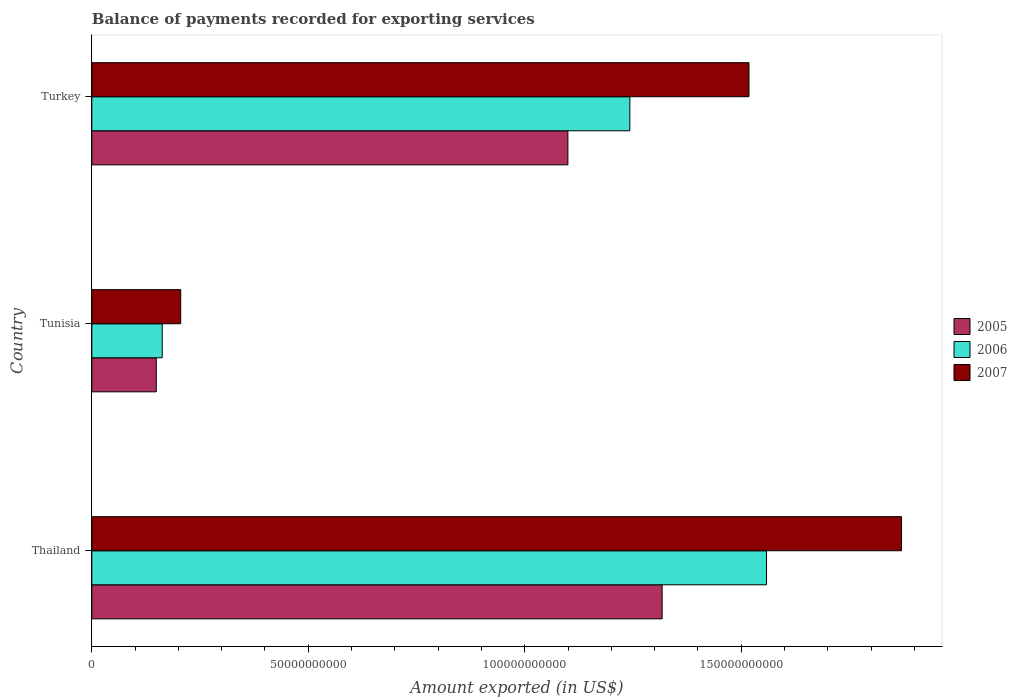How many different coloured bars are there?
Give a very brief answer. 3. Are the number of bars per tick equal to the number of legend labels?
Keep it short and to the point. Yes. How many bars are there on the 2nd tick from the bottom?
Offer a very short reply. 3. What is the label of the 3rd group of bars from the top?
Offer a very short reply. Thailand. What is the amount exported in 2007 in Thailand?
Give a very brief answer. 1.87e+11. Across all countries, what is the maximum amount exported in 2005?
Provide a short and direct response. 1.32e+11. Across all countries, what is the minimum amount exported in 2006?
Give a very brief answer. 1.63e+1. In which country was the amount exported in 2005 maximum?
Offer a terse response. Thailand. In which country was the amount exported in 2006 minimum?
Provide a short and direct response. Tunisia. What is the total amount exported in 2007 in the graph?
Offer a terse response. 3.59e+11. What is the difference between the amount exported in 2006 in Tunisia and that in Turkey?
Your response must be concise. -1.08e+11. What is the difference between the amount exported in 2006 in Thailand and the amount exported in 2007 in Turkey?
Your answer should be compact. 4.06e+09. What is the average amount exported in 2007 per country?
Ensure brevity in your answer.  1.20e+11. What is the difference between the amount exported in 2005 and amount exported in 2006 in Thailand?
Offer a terse response. -2.41e+1. In how many countries, is the amount exported in 2005 greater than 70000000000 US$?
Ensure brevity in your answer.  2. What is the ratio of the amount exported in 2006 in Tunisia to that in Turkey?
Your answer should be compact. 0.13. Is the amount exported in 2006 in Thailand less than that in Tunisia?
Ensure brevity in your answer.  No. Is the difference between the amount exported in 2005 in Thailand and Turkey greater than the difference between the amount exported in 2006 in Thailand and Turkey?
Keep it short and to the point. No. What is the difference between the highest and the second highest amount exported in 2006?
Your response must be concise. 3.16e+1. What is the difference between the highest and the lowest amount exported in 2007?
Provide a short and direct response. 1.67e+11. Is the sum of the amount exported in 2006 in Tunisia and Turkey greater than the maximum amount exported in 2005 across all countries?
Your response must be concise. Yes. What does the 1st bar from the top in Thailand represents?
Keep it short and to the point. 2007. Is it the case that in every country, the sum of the amount exported in 2006 and amount exported in 2007 is greater than the amount exported in 2005?
Offer a very short reply. Yes. How many bars are there?
Ensure brevity in your answer.  9. Are all the bars in the graph horizontal?
Your answer should be very brief. Yes. How many countries are there in the graph?
Give a very brief answer. 3. What is the difference between two consecutive major ticks on the X-axis?
Offer a very short reply. 5.00e+1. Does the graph contain grids?
Provide a succinct answer. No. Where does the legend appear in the graph?
Your answer should be very brief. Center right. How many legend labels are there?
Give a very brief answer. 3. How are the legend labels stacked?
Your answer should be compact. Vertical. What is the title of the graph?
Give a very brief answer. Balance of payments recorded for exporting services. Does "1995" appear as one of the legend labels in the graph?
Offer a terse response. No. What is the label or title of the X-axis?
Your response must be concise. Amount exported (in US$). What is the Amount exported (in US$) in 2005 in Thailand?
Make the answer very short. 1.32e+11. What is the Amount exported (in US$) in 2006 in Thailand?
Make the answer very short. 1.56e+11. What is the Amount exported (in US$) in 2007 in Thailand?
Make the answer very short. 1.87e+11. What is the Amount exported (in US$) in 2005 in Tunisia?
Offer a terse response. 1.49e+1. What is the Amount exported (in US$) in 2006 in Tunisia?
Your answer should be compact. 1.63e+1. What is the Amount exported (in US$) in 2007 in Tunisia?
Ensure brevity in your answer.  2.05e+1. What is the Amount exported (in US$) of 2005 in Turkey?
Make the answer very short. 1.10e+11. What is the Amount exported (in US$) in 2006 in Turkey?
Give a very brief answer. 1.24e+11. What is the Amount exported (in US$) of 2007 in Turkey?
Offer a very short reply. 1.52e+11. Across all countries, what is the maximum Amount exported (in US$) of 2005?
Provide a succinct answer. 1.32e+11. Across all countries, what is the maximum Amount exported (in US$) in 2006?
Your response must be concise. 1.56e+11. Across all countries, what is the maximum Amount exported (in US$) of 2007?
Ensure brevity in your answer.  1.87e+11. Across all countries, what is the minimum Amount exported (in US$) in 2005?
Provide a succinct answer. 1.49e+1. Across all countries, what is the minimum Amount exported (in US$) in 2006?
Provide a short and direct response. 1.63e+1. Across all countries, what is the minimum Amount exported (in US$) of 2007?
Provide a succinct answer. 2.05e+1. What is the total Amount exported (in US$) of 2005 in the graph?
Your response must be concise. 2.57e+11. What is the total Amount exported (in US$) of 2006 in the graph?
Your answer should be compact. 2.96e+11. What is the total Amount exported (in US$) of 2007 in the graph?
Provide a succinct answer. 3.59e+11. What is the difference between the Amount exported (in US$) in 2005 in Thailand and that in Tunisia?
Ensure brevity in your answer.  1.17e+11. What is the difference between the Amount exported (in US$) of 2006 in Thailand and that in Tunisia?
Offer a very short reply. 1.40e+11. What is the difference between the Amount exported (in US$) of 2007 in Thailand and that in Tunisia?
Keep it short and to the point. 1.67e+11. What is the difference between the Amount exported (in US$) of 2005 in Thailand and that in Turkey?
Your answer should be very brief. 2.18e+1. What is the difference between the Amount exported (in US$) of 2006 in Thailand and that in Turkey?
Give a very brief answer. 3.16e+1. What is the difference between the Amount exported (in US$) of 2007 in Thailand and that in Turkey?
Your answer should be very brief. 3.52e+1. What is the difference between the Amount exported (in US$) of 2005 in Tunisia and that in Turkey?
Provide a succinct answer. -9.51e+1. What is the difference between the Amount exported (in US$) in 2006 in Tunisia and that in Turkey?
Offer a very short reply. -1.08e+11. What is the difference between the Amount exported (in US$) of 2007 in Tunisia and that in Turkey?
Give a very brief answer. -1.31e+11. What is the difference between the Amount exported (in US$) in 2005 in Thailand and the Amount exported (in US$) in 2006 in Tunisia?
Offer a very short reply. 1.15e+11. What is the difference between the Amount exported (in US$) of 2005 in Thailand and the Amount exported (in US$) of 2007 in Tunisia?
Keep it short and to the point. 1.11e+11. What is the difference between the Amount exported (in US$) in 2006 in Thailand and the Amount exported (in US$) in 2007 in Tunisia?
Make the answer very short. 1.35e+11. What is the difference between the Amount exported (in US$) of 2005 in Thailand and the Amount exported (in US$) of 2006 in Turkey?
Ensure brevity in your answer.  7.46e+09. What is the difference between the Amount exported (in US$) in 2005 in Thailand and the Amount exported (in US$) in 2007 in Turkey?
Your answer should be compact. -2.01e+1. What is the difference between the Amount exported (in US$) in 2006 in Thailand and the Amount exported (in US$) in 2007 in Turkey?
Offer a terse response. 4.06e+09. What is the difference between the Amount exported (in US$) of 2005 in Tunisia and the Amount exported (in US$) of 2006 in Turkey?
Your answer should be very brief. -1.09e+11. What is the difference between the Amount exported (in US$) in 2005 in Tunisia and the Amount exported (in US$) in 2007 in Turkey?
Offer a terse response. -1.37e+11. What is the difference between the Amount exported (in US$) of 2006 in Tunisia and the Amount exported (in US$) of 2007 in Turkey?
Your response must be concise. -1.36e+11. What is the average Amount exported (in US$) in 2005 per country?
Offer a very short reply. 8.55e+1. What is the average Amount exported (in US$) of 2006 per country?
Offer a terse response. 9.88e+1. What is the average Amount exported (in US$) in 2007 per country?
Give a very brief answer. 1.20e+11. What is the difference between the Amount exported (in US$) of 2005 and Amount exported (in US$) of 2006 in Thailand?
Give a very brief answer. -2.41e+1. What is the difference between the Amount exported (in US$) of 2005 and Amount exported (in US$) of 2007 in Thailand?
Offer a terse response. -5.53e+1. What is the difference between the Amount exported (in US$) of 2006 and Amount exported (in US$) of 2007 in Thailand?
Your answer should be very brief. -3.12e+1. What is the difference between the Amount exported (in US$) in 2005 and Amount exported (in US$) in 2006 in Tunisia?
Your answer should be compact. -1.37e+09. What is the difference between the Amount exported (in US$) of 2005 and Amount exported (in US$) of 2007 in Tunisia?
Offer a terse response. -5.64e+09. What is the difference between the Amount exported (in US$) in 2006 and Amount exported (in US$) in 2007 in Tunisia?
Give a very brief answer. -4.27e+09. What is the difference between the Amount exported (in US$) of 2005 and Amount exported (in US$) of 2006 in Turkey?
Your response must be concise. -1.43e+1. What is the difference between the Amount exported (in US$) in 2005 and Amount exported (in US$) in 2007 in Turkey?
Offer a terse response. -4.18e+1. What is the difference between the Amount exported (in US$) in 2006 and Amount exported (in US$) in 2007 in Turkey?
Provide a succinct answer. -2.75e+1. What is the ratio of the Amount exported (in US$) of 2005 in Thailand to that in Tunisia?
Provide a succinct answer. 8.85. What is the ratio of the Amount exported (in US$) in 2006 in Thailand to that in Tunisia?
Keep it short and to the point. 9.59. What is the ratio of the Amount exported (in US$) of 2007 in Thailand to that in Tunisia?
Keep it short and to the point. 9.11. What is the ratio of the Amount exported (in US$) in 2005 in Thailand to that in Turkey?
Keep it short and to the point. 1.2. What is the ratio of the Amount exported (in US$) in 2006 in Thailand to that in Turkey?
Provide a short and direct response. 1.25. What is the ratio of the Amount exported (in US$) in 2007 in Thailand to that in Turkey?
Give a very brief answer. 1.23. What is the ratio of the Amount exported (in US$) in 2005 in Tunisia to that in Turkey?
Provide a short and direct response. 0.14. What is the ratio of the Amount exported (in US$) in 2006 in Tunisia to that in Turkey?
Keep it short and to the point. 0.13. What is the ratio of the Amount exported (in US$) in 2007 in Tunisia to that in Turkey?
Keep it short and to the point. 0.14. What is the difference between the highest and the second highest Amount exported (in US$) in 2005?
Your response must be concise. 2.18e+1. What is the difference between the highest and the second highest Amount exported (in US$) of 2006?
Keep it short and to the point. 3.16e+1. What is the difference between the highest and the second highest Amount exported (in US$) in 2007?
Make the answer very short. 3.52e+1. What is the difference between the highest and the lowest Amount exported (in US$) in 2005?
Give a very brief answer. 1.17e+11. What is the difference between the highest and the lowest Amount exported (in US$) in 2006?
Provide a succinct answer. 1.40e+11. What is the difference between the highest and the lowest Amount exported (in US$) of 2007?
Your response must be concise. 1.67e+11. 